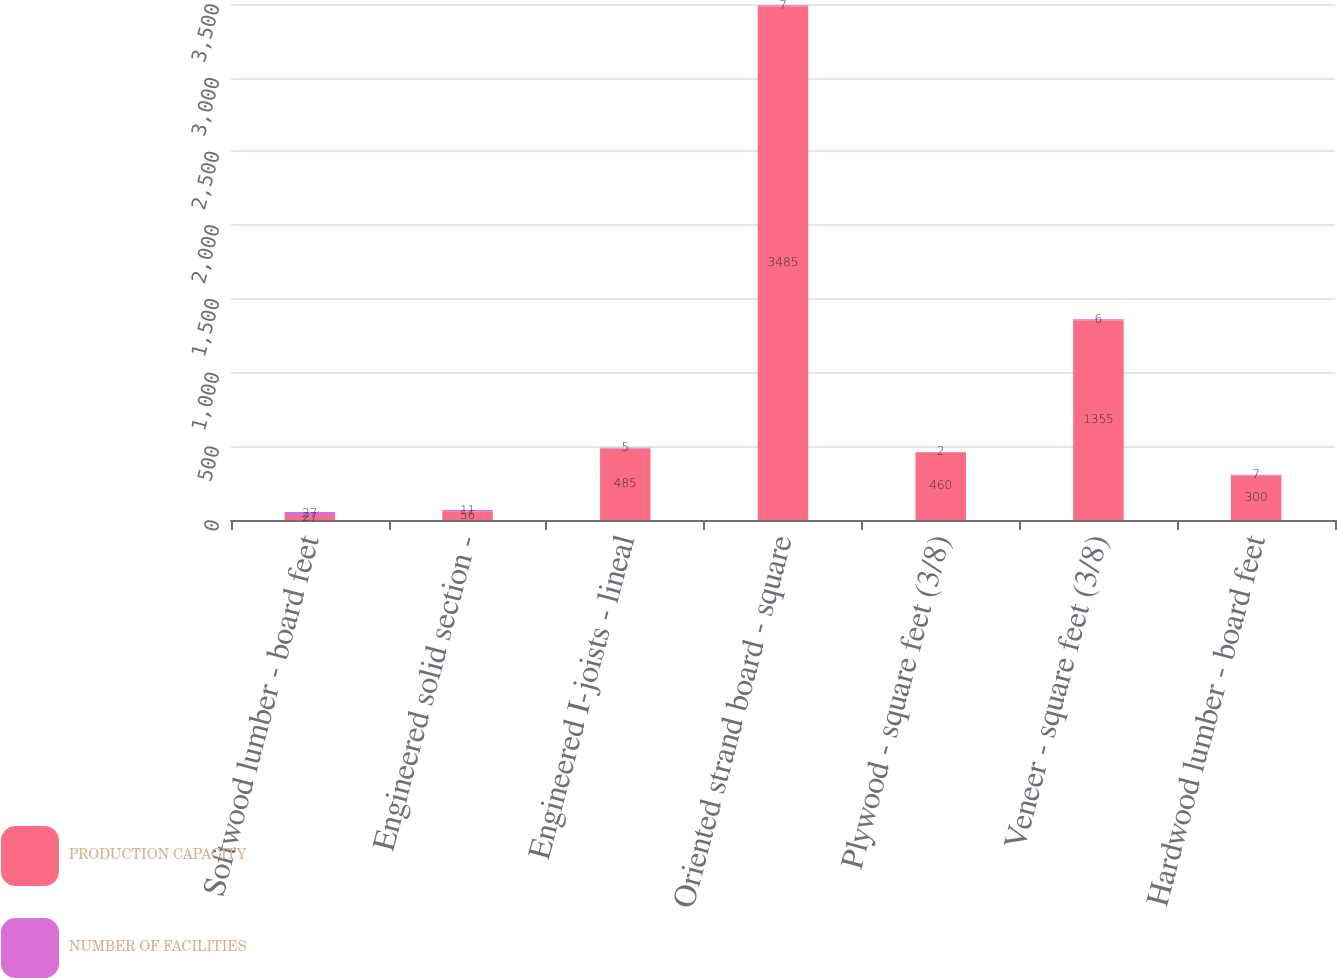<chart> <loc_0><loc_0><loc_500><loc_500><stacked_bar_chart><ecel><fcel>Softwood lumber - board feet<fcel>Engineered solid section -<fcel>Engineered I-joists - lineal<fcel>Oriented strand board - square<fcel>Plywood - square feet (3/8)<fcel>Veneer - square feet (3/8)<fcel>Hardwood lumber - board feet<nl><fcel>PRODUCTION CAPACITY<fcel>27<fcel>56<fcel>485<fcel>3485<fcel>460<fcel>1355<fcel>300<nl><fcel>NUMBER OF FACILITIES<fcel>27<fcel>11<fcel>5<fcel>7<fcel>2<fcel>6<fcel>7<nl></chart> 